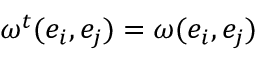<formula> <loc_0><loc_0><loc_500><loc_500>\omega ^ { t } ( e _ { i } , e _ { j } ) = \omega ( e _ { i } , e _ { j } )</formula> 